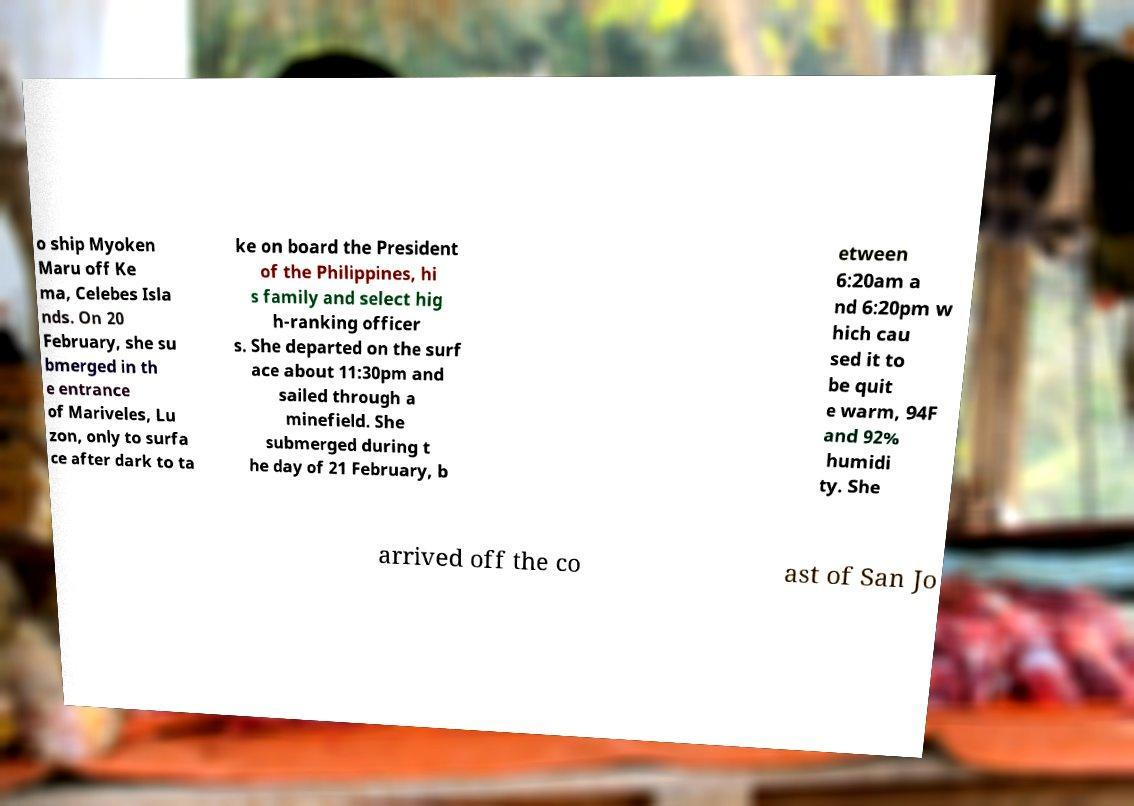For documentation purposes, I need the text within this image transcribed. Could you provide that? o ship Myoken Maru off Ke ma, Celebes Isla nds. On 20 February, she su bmerged in th e entrance of Mariveles, Lu zon, only to surfa ce after dark to ta ke on board the President of the Philippines, hi s family and select hig h-ranking officer s. She departed on the surf ace about 11:30pm and sailed through a minefield. She submerged during t he day of 21 February, b etween 6:20am a nd 6:20pm w hich cau sed it to be quit e warm, 94F and 92% humidi ty. She arrived off the co ast of San Jo 